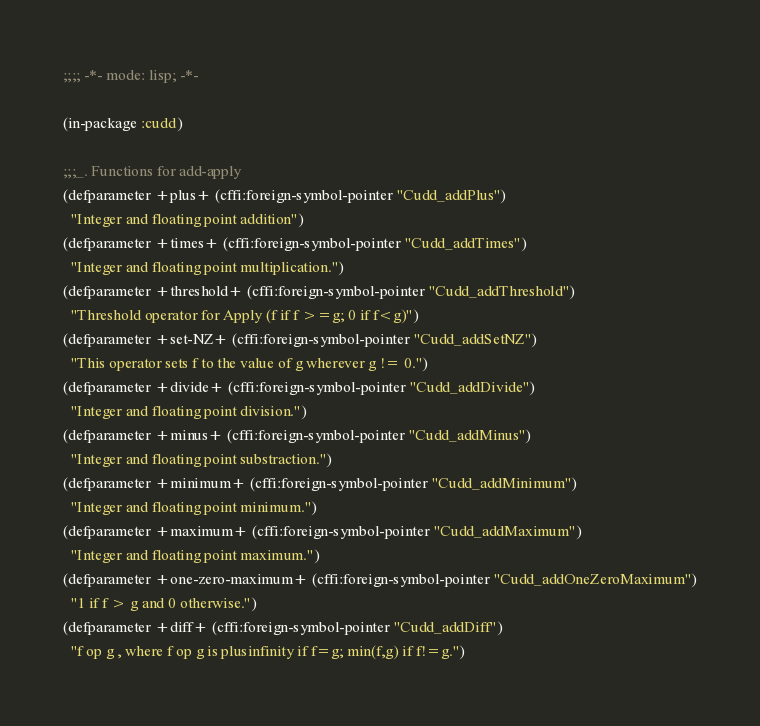Convert code to text. <code><loc_0><loc_0><loc_500><loc_500><_Lisp_>;;;; -*- mode: lisp; -*-

(in-package :cudd)

;;;_. Functions for add-apply
(defparameter +plus+ (cffi:foreign-symbol-pointer "Cudd_addPlus")
  "Integer and floating point addition")
(defparameter +times+ (cffi:foreign-symbol-pointer "Cudd_addTimes")
  "Integer and floating point multiplication.")
(defparameter +threshold+ (cffi:foreign-symbol-pointer "Cudd_addThreshold")
  "Threshold operator for Apply (f if f >=g; 0 if f<g)")
(defparameter +set-NZ+ (cffi:foreign-symbol-pointer "Cudd_addSetNZ")
  "This operator sets f to the value of g wherever g != 0.")
(defparameter +divide+ (cffi:foreign-symbol-pointer "Cudd_addDivide")
  "Integer and floating point division.")
(defparameter +minus+ (cffi:foreign-symbol-pointer "Cudd_addMinus")
  "Integer and floating point substraction.")
(defparameter +minimum+ (cffi:foreign-symbol-pointer "Cudd_addMinimum")
  "Integer and floating point minimum.")
(defparameter +maximum+ (cffi:foreign-symbol-pointer "Cudd_addMaximum")
  "Integer and floating point maximum.")
(defparameter +one-zero-maximum+ (cffi:foreign-symbol-pointer "Cudd_addOneZeroMaximum")
  "1 if f > g and 0 otherwise.")
(defparameter +diff+ (cffi:foreign-symbol-pointer "Cudd_addDiff")
  "f op g , where f op g is plusinfinity if f=g; min(f,g) if f!=g.")</code> 